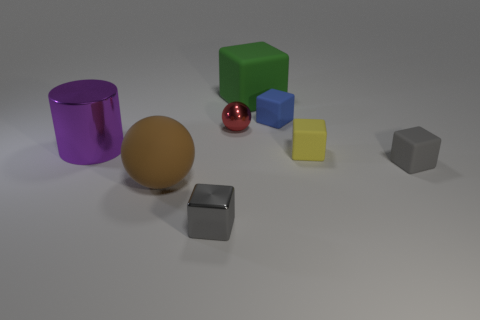Is the number of red metal spheres to the right of the big green cube greater than the number of yellow objects that are in front of the big purple shiny thing?
Give a very brief answer. No. What number of things are either large rubber objects left of the gray metal block or matte blocks?
Provide a succinct answer. 5. There is a gray thing that is the same material as the small red thing; what shape is it?
Keep it short and to the point. Cube. Is there anything else that is the same shape as the large purple shiny object?
Offer a very short reply. No. There is a matte thing that is both left of the blue block and in front of the red sphere; what is its color?
Offer a terse response. Brown. How many cylinders are large yellow rubber objects or small metal things?
Ensure brevity in your answer.  0. How many purple objects are the same size as the green matte block?
Offer a terse response. 1. What number of red shiny objects are right of the big rubber thing behind the red thing?
Make the answer very short. 0. What is the size of the metal thing that is behind the big matte sphere and on the right side of the purple shiny object?
Give a very brief answer. Small. Are there more purple things than big blue spheres?
Your answer should be very brief. Yes. 